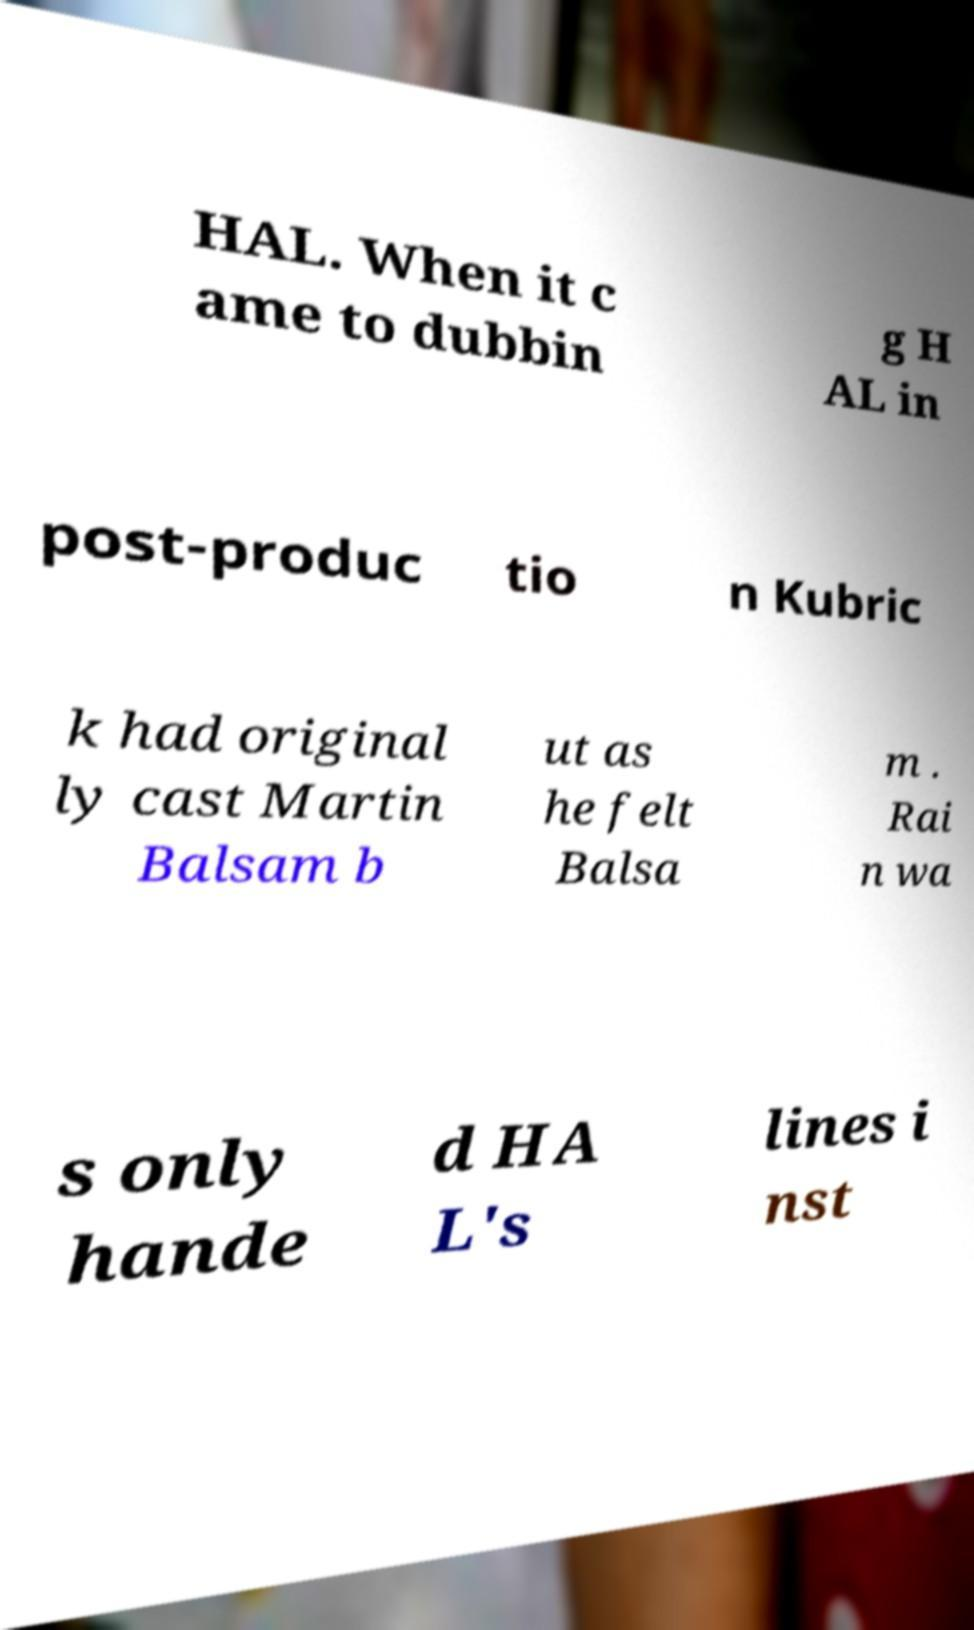Please read and relay the text visible in this image. What does it say? HAL. When it c ame to dubbin g H AL in post-produc tio n Kubric k had original ly cast Martin Balsam b ut as he felt Balsa m . Rai n wa s only hande d HA L's lines i nst 